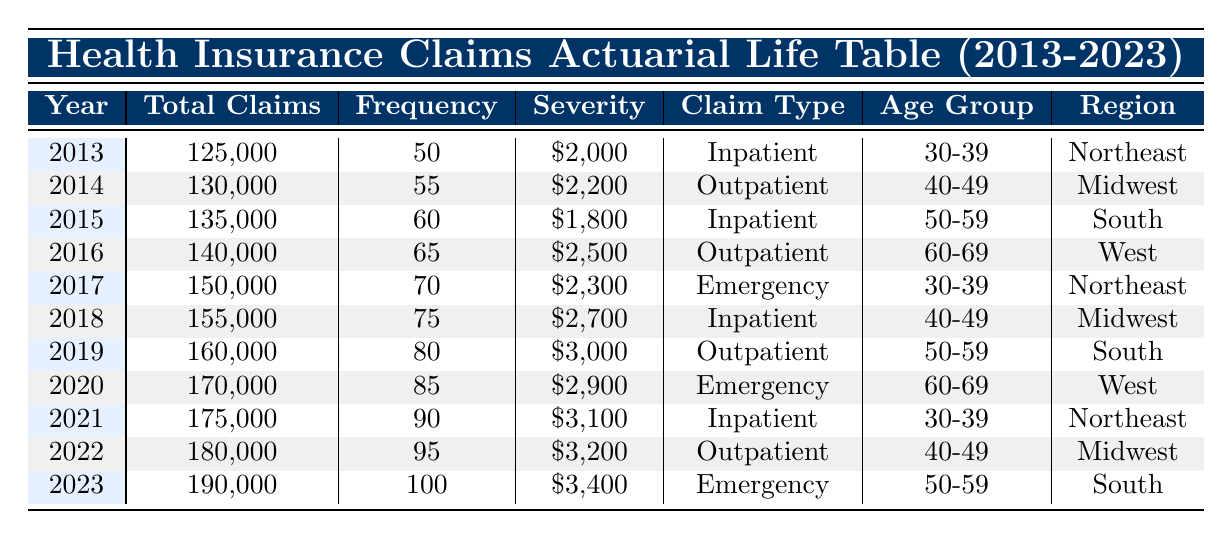What was the total number of claims in 2020? The table lists the total claims for each year. For 2020, the value is directly given as 170,000 claims.
Answer: 170000 In which year did the highest severity occur and what was its value? The severity values for each year are listed in the table. The highest severity value is 3,400, which occurred in 2023.
Answer: 2023 and 3400 What is the average frequency of claims over the years 2013 to 2023? The frequency values from the table are: 50, 55, 60, 65, 70, 75, 80, 85, 90, 95, 100. There are 11 values. The sum is  50 + 55 + 60 + 65 + 70 + 75 + 80 + 85 + 90 + 95 + 100 =  1,025. Dividing by 11 (1025/11) gives an average frequency of approximately 93.18.
Answer: 93.18 Are there any years where the claim type was 'Emergency'? Looking through the table, the years with an 'Emergency' claim type are 2017, 2020, and 2023. Therefore, there are several years with this claim type.
Answer: Yes What was the trend in total claims from 2013 to 2023? The total claims started at 125,000 in 2013 and increased to 190,000 in 2023. Observing the data, it shows a consistent increase each year: 125,000 → 130,000 → 135,000 → 140,000 → 150,000 → 155,000 → 160,000 → 170,000 → 175,000 → 180,000 → 190,000. The pattern indicates a positive growth trend in total claims.
Answer: The total claims trended upward In what region were the most recent inpatient claims recorded? Referring to the last year listed, 2023, the claim type is 'Emergency', not 'Inpatient'. For inpatient claims, the last occurrence was in 2021, and the region was 'Northeast'.
Answer: Northeast 